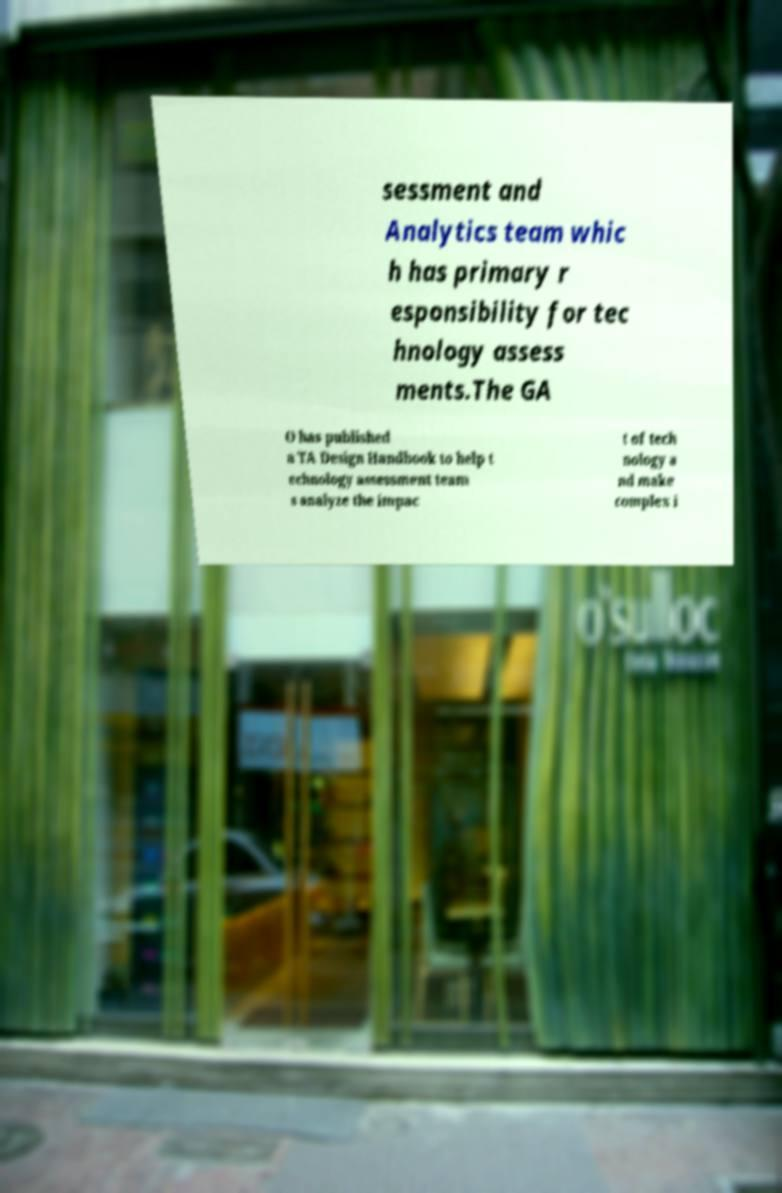Could you assist in decoding the text presented in this image and type it out clearly? sessment and Analytics team whic h has primary r esponsibility for tec hnology assess ments.The GA O has published a TA Design Handbook to help t echnology assessment team s analyze the impac t of tech nology a nd make complex i 